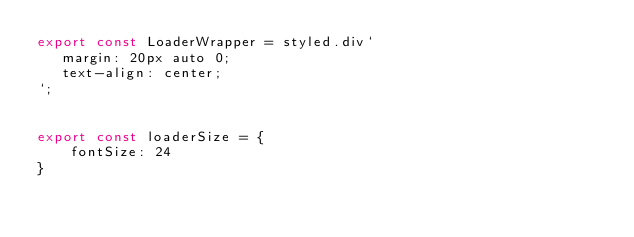Convert code to text. <code><loc_0><loc_0><loc_500><loc_500><_JavaScript_>export const LoaderWrapper = styled.div`
   margin: 20px auto 0;
   text-align: center;
`;


export const loaderSize = {
    fontSize: 24
}





</code> 